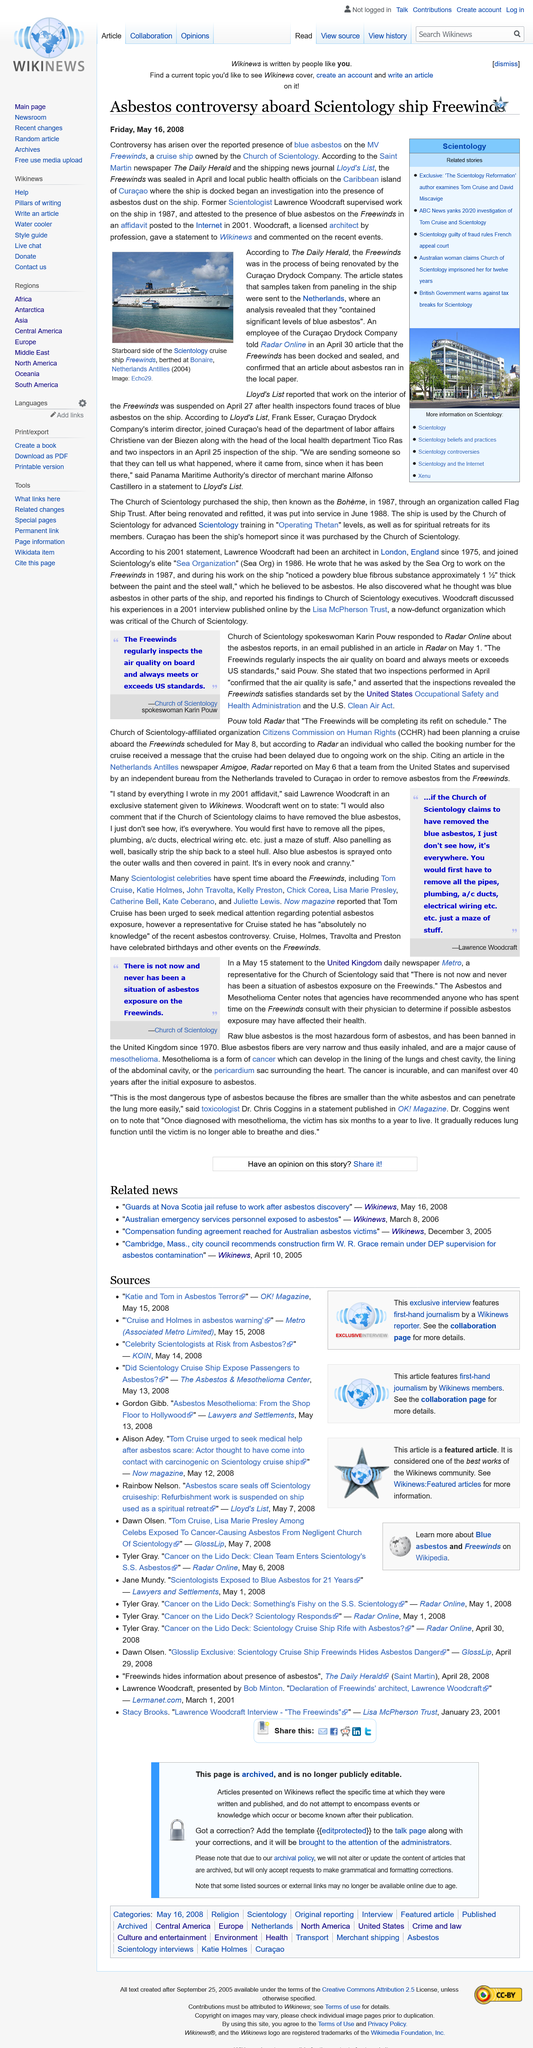Highlight a few significant elements in this photo. The British Government has warned against tax breaks for Scientology. Blue asbestos was discovered on the MV Freewinds, a cruise ship owned by the Church of Scientology. The paneling samples from the ship were sent to the Netherlands. 